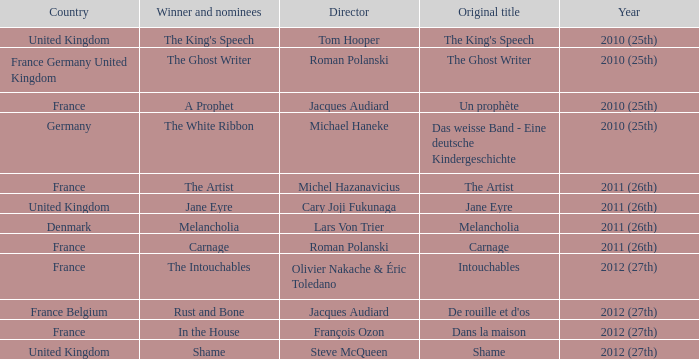Who was the winner and nominees for the movie directed by cary joji fukunaga? Jane Eyre. 